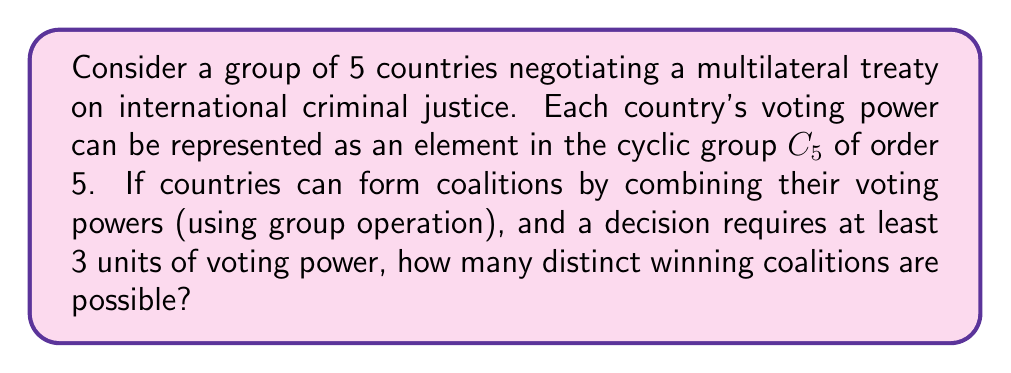Can you solve this math problem? To solve this problem, we need to apply group theory concepts to the given scenario:

1) The cyclic group $C_5$ of order 5 can be represented as $\{0, 1, 2, 3, 4\}$ under addition modulo 5.

2) Each country's voting power corresponds to an element in this group.

3) Coalitions are formed by combining voting powers, which is equivalent to adding the corresponding group elements.

4) A winning coalition needs at least 3 units of voting power.

5) We need to count the number of distinct subsets of $C_5$ whose elements sum to 3 or more (mod 5).

Let's enumerate the possibilities:

- Single country coalitions: $\{3\}, \{4\}$ (2 coalitions)
- Two country coalitions: $\{1,2\}, \{1,3\}, \{1,4\}, \{2,3\}, \{2,4\}, \{3,4\}$ (6 coalitions)
- Three country coalitions: $\{0,1,2\}, \{0,1,3\}, \{0,1,4\}, \{0,2,3\}, \{0,2,4\}, \{0,3,4\}, \{1,2,3\}, \{1,2,4\}, \{1,3,4\}, \{2,3,4\}$ (10 coalitions)
- Four country coalitions: $\{0,1,2,3\}, \{0,1,2,4\}, \{0,1,3,4\}, \{0,2,3,4\}, \{1,2,3,4\}$ (5 coalitions)
- Five country coalition: $\{0,1,2,3,4\}$ (1 coalition)

The total number of distinct winning coalitions is the sum of all these: 2 + 6 + 10 + 5 + 1 = 24.
Answer: 24 distinct winning coalitions 